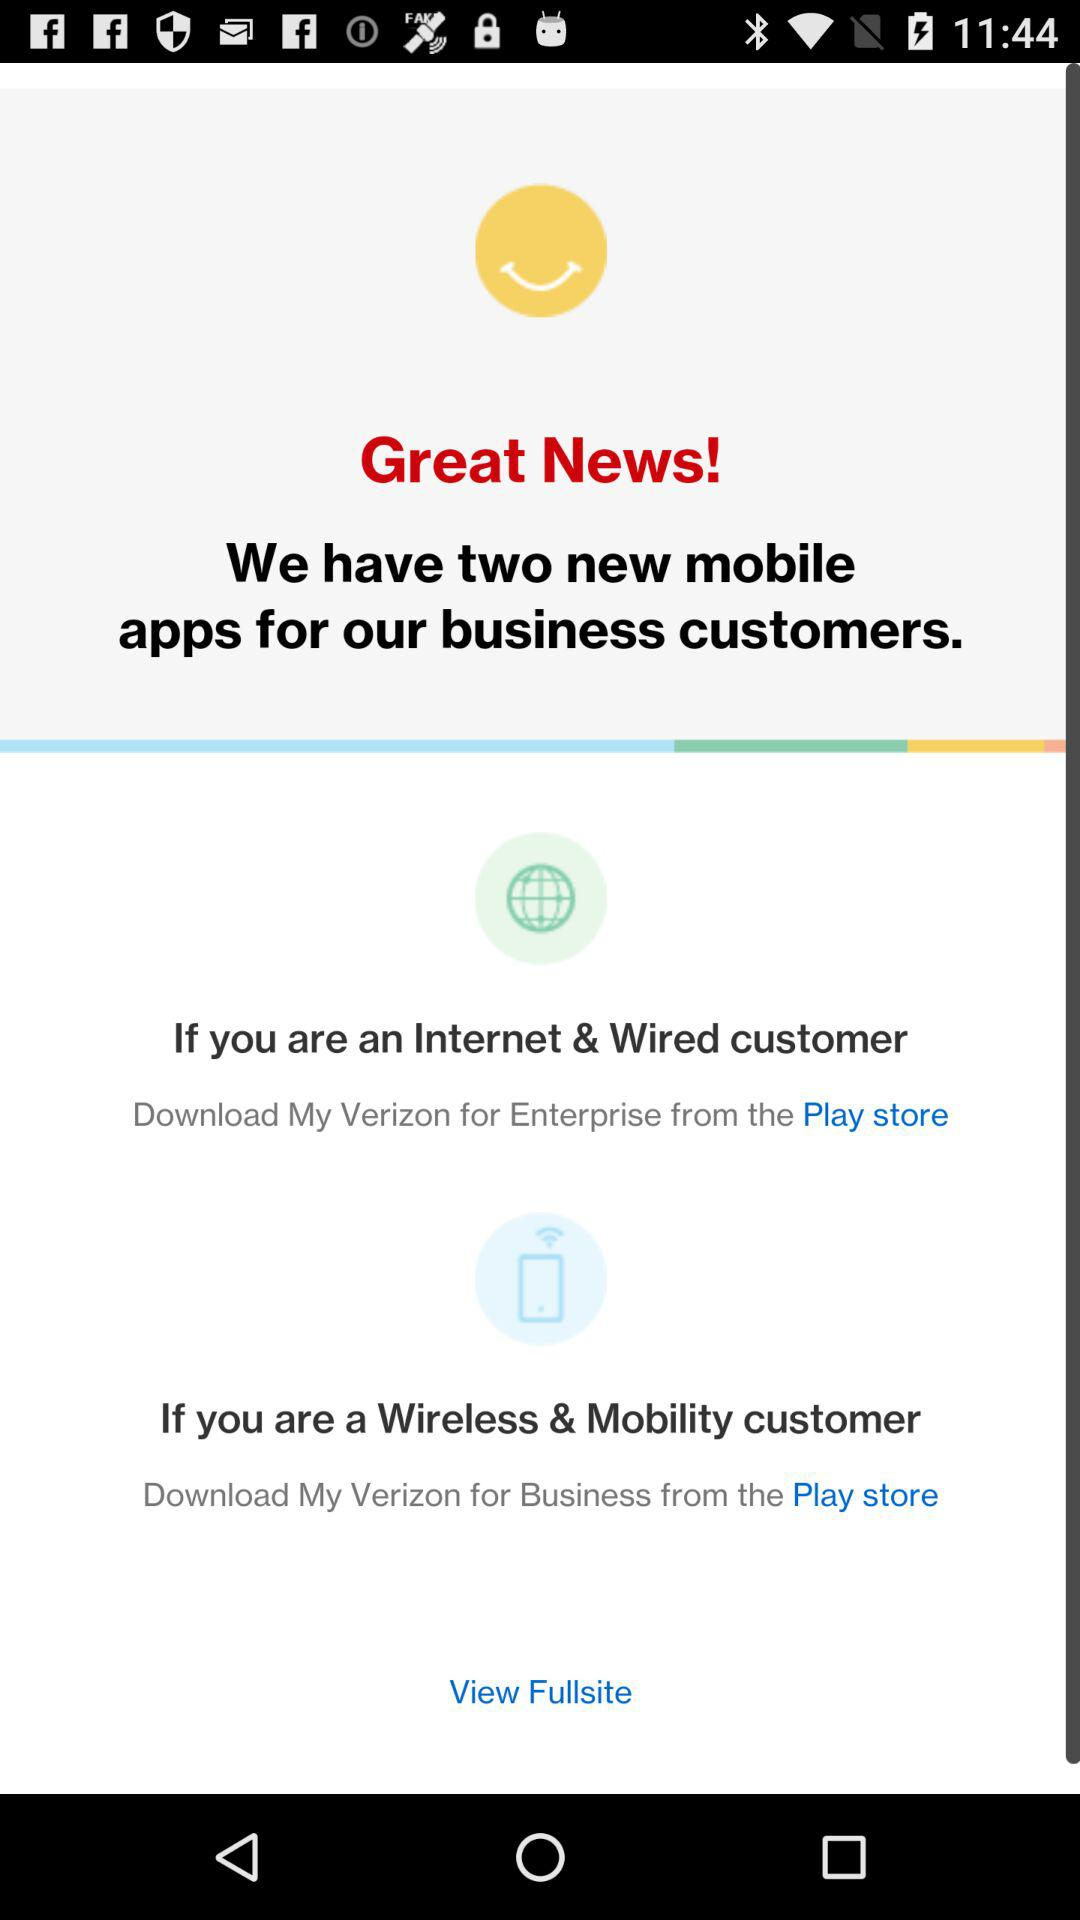How many apps are available for business customers?
Answer the question using a single word or phrase. 2 